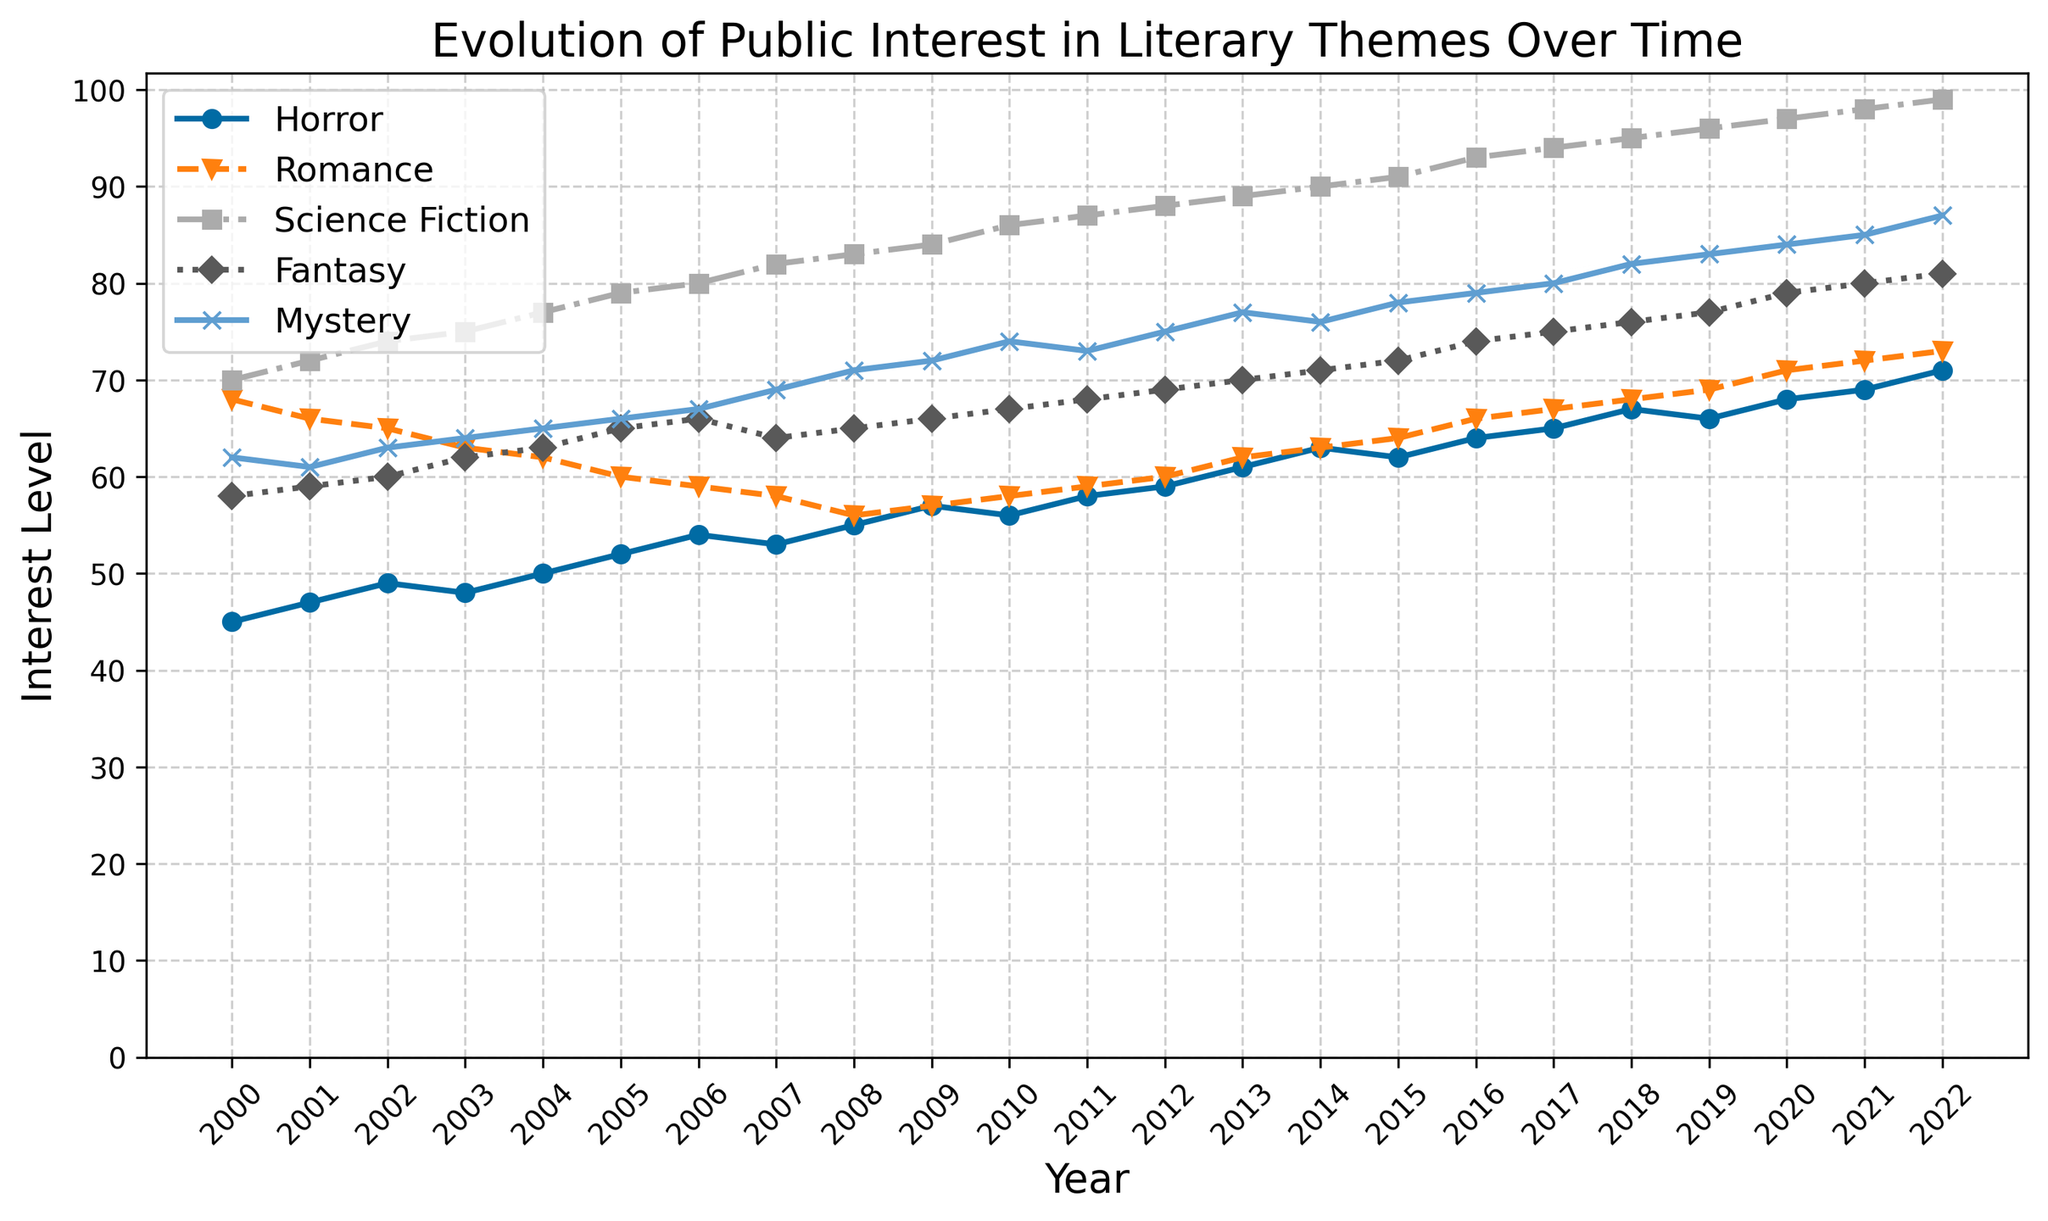What is the literary theme with the highest interest in 2022? Looking at the line chart for the year 2022, find the line that reaches the highest point of the y-axis. The line for "Science Fiction" is the highest with a value of 99.
Answer: Science Fiction Which theme experienced the most consistent increase from 2000 to 2022? Evaluate the trend of each line from 2000 to 2022. The "Science Fiction" line shows the most consistent and steady upward trend without significant dips.
Answer: Science Fiction At what year did Fantasy surpass Horror in interest? Compare the "Fantasy" and "Horror" lines year by year starting from 2000. In 2003, Fantasy (value 62) surpasses Horror (value 48).
Answer: 2003 What is the difference in interest level between Romance and Mystery in 2022? Find the values for Romance and Mystery in 2022. Romance is at 73, and Mystery is at 87. Compute the difference: 87 - 73.
Answer: 14 Which theme has the least variation in interest level over the years? Assess the fluctuation in each theme’s line. "Fantasy" presents the least variation with a steady incremental rise.
Answer: Fantasy How has public interest in Horror changed from 2007 to 2017? Look at the "Horror" line at the years 2007 and 2017. Horror starts at 53 in 2007 and increases to 65 in 2017.
Answer: Increased During what period did Romance see the biggest decline in interest? Find periods where the "Romance" line dips. The most notable decline is from 2000 (value 68) to 2008 (value 56).
Answer: 2000-2008 What is the trend in public interest for Mystery from 2015 to 2020? Observe the "Mystery" line from 2015 (value 78) to 2020 (value 84). The interest level shows an upward trend.
Answer: Increasing Which two themes had almost equal interest around the year 2009? Check for lines that are close to each other around 2009. "Romance" and "Horror" were close at values 57 and 56 respectively.
Answer: Romance and Horror What was the average interest level in Science Fiction for the years 2020 to 2022? Find the values for Science Fiction from 2020 (97), 2021 (98), and 2022 (99). Sum these values and divide by 3. (97 + 98 + 99) / 3 = 98.
Answer: 98 